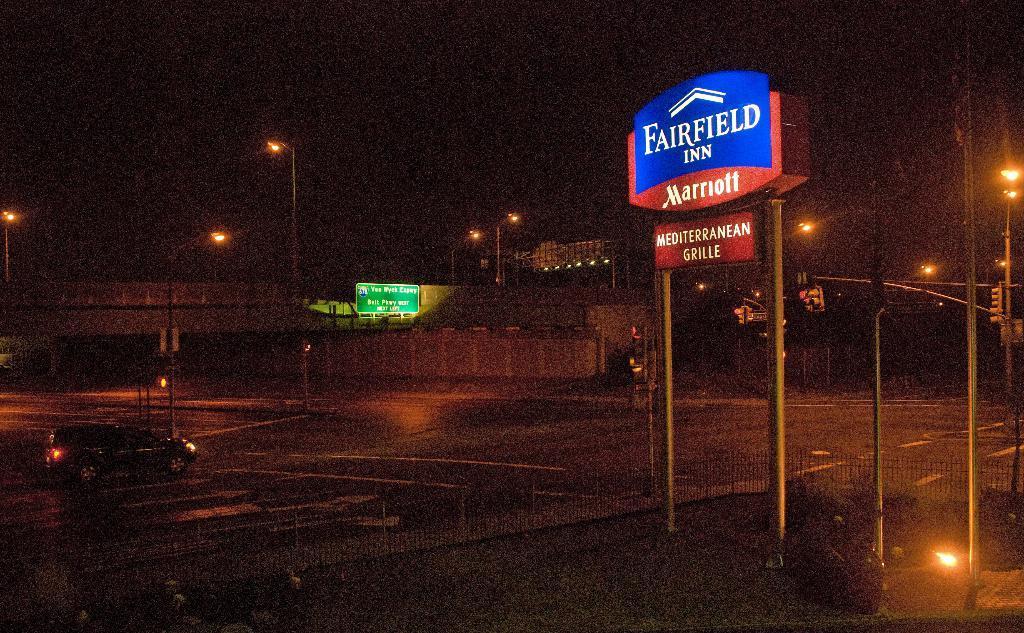How would you summarize this image in a sentence or two? In this image there is a car passing on the road, beside the car there is a bridge, lamp posts, name boards, metal fence and traffic lights. 